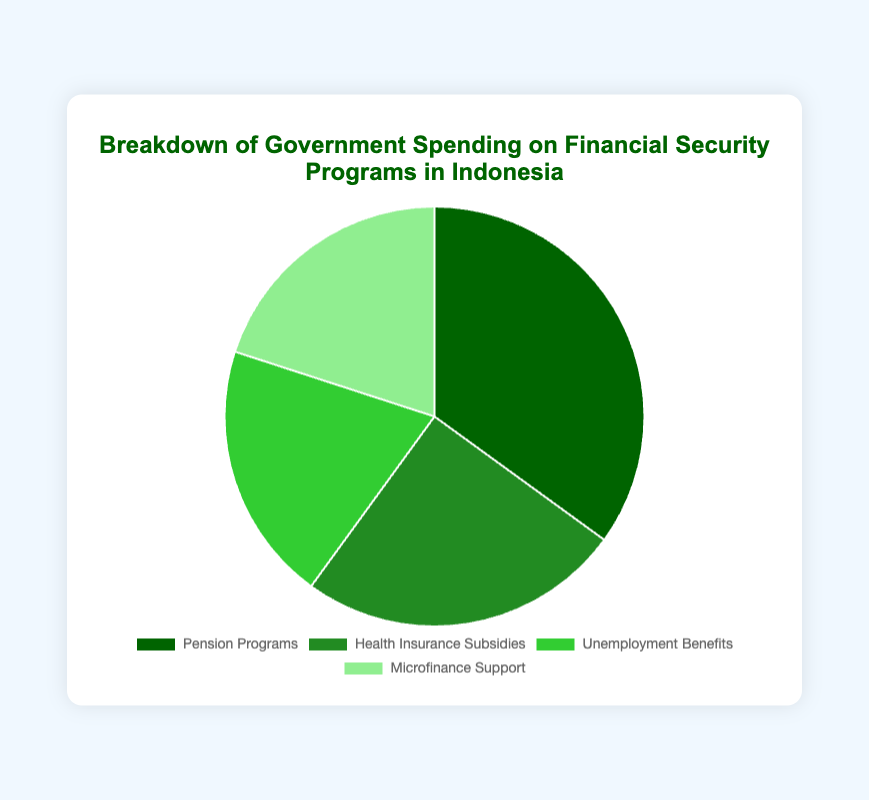What's the largest category of government spending on financial security programs? The Pension Programs represent the largest slice of the pie chart at 35%.
Answer: Pension Programs What percentage of the government spending is allocated to Microfinance Support? The chart shows that Microfinance Support occupies a 20% portion of the government spending.
Answer: 20% Compare the spending on Pension Programs and Health Insurance Subsidies. Which is higher and by how much? The spending on Pension Programs is 35% while Health Insurance Subsidies is 25%. The difference is 35% - 25% = 10%.
Answer: Pension Programs by 10% Is the spending on Unemployment Benefits equal to the spending on Microfinance Support? Both Unemployment Benefits and Microfinance Support each make up 20% of the spending, indicating they are equal.
Answer: Yes What is the total percentage of government spending on programs other than Pension Programs? The chart shows Pension Programs at 35%; therefore, the total for the other programs is 100% - 35% = 65%.
Answer: 65% How does the combined spending on Health Insurance Subsidies and Unemployment Benefits compare to the spending on Pension Programs? Health Insurance Subsidies (25%) + Unemployment Benefits (20%) = 45%, which is higher than the 35% spent on Pension Programs by 10%.
Answer: Higher by 10% What portion of the government's spending is directed towards Unemployment Benefits and Microfinance Support together? The chart indicates both Unemployment Benefits and Microfinance Support at 20% each, so combined that is 20% + 20% = 40%.
Answer: 40% Considering color coding, which program is represented by the lightest shade of green and what is its percentage? The pie chart uses the lightest shade of green for Microfinance Support, which constitutes 20% of the spending.
Answer: Microfinance Support, 20% Calculate the difference in spending between Health Insurance Subsidies and the average spending of all the programs. The average spending is (35% + 25% + 20% + 20%) / 4 = 25%. The difference is 25% - 25% = 0%.
Answer: 0% Which program has less spending, Unemployment Benefits or Health Insurance Subsidies, and by what percentage? Unemployment Benefits are at 20% while Health Insurance Subsidies are at 25%. The difference is 25% - 20% = 5%.
Answer: Unemployment Benefits by 5% 